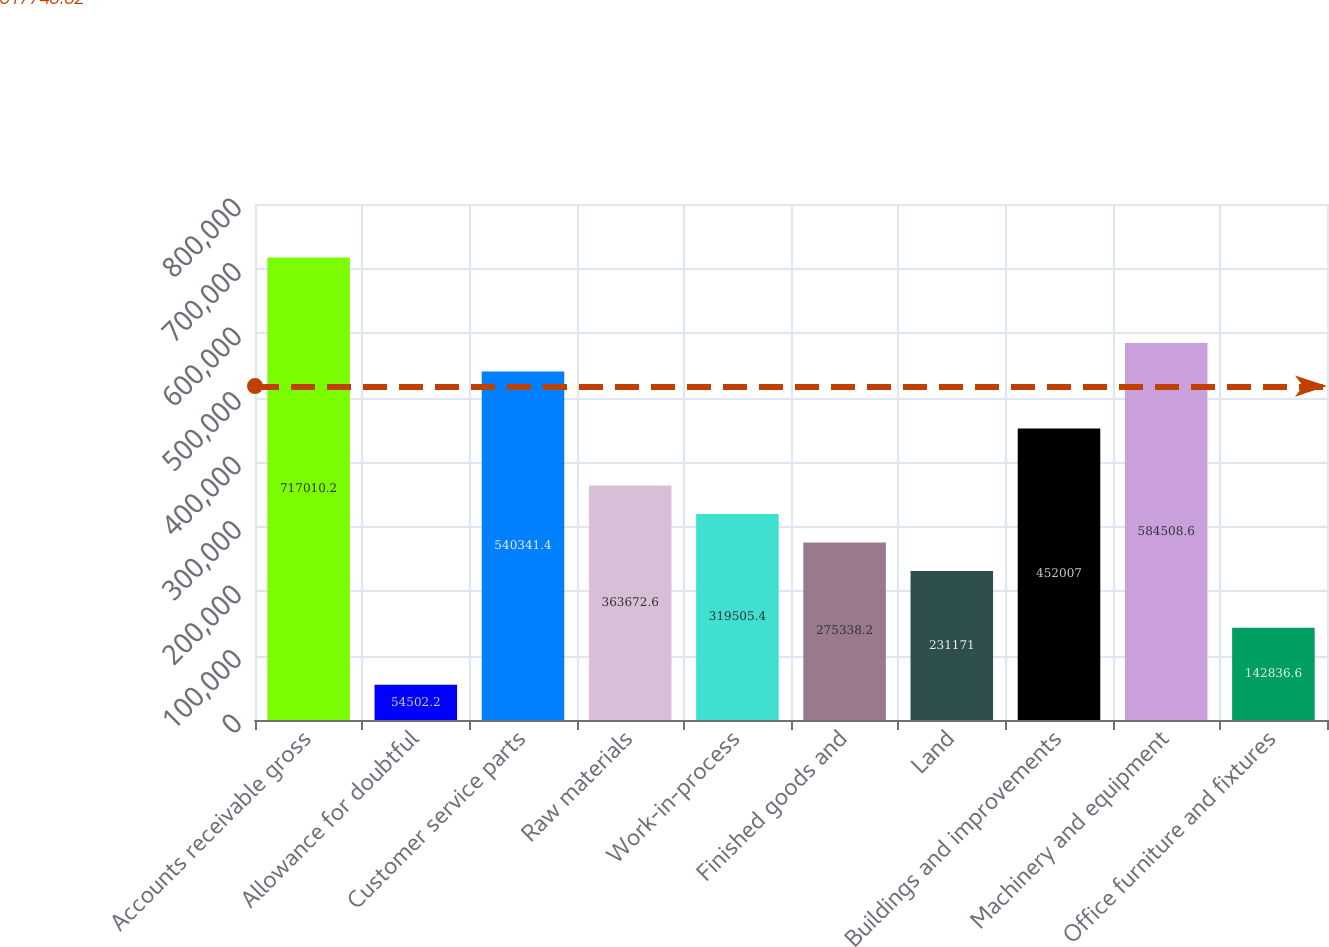<chart> <loc_0><loc_0><loc_500><loc_500><bar_chart><fcel>Accounts receivable gross<fcel>Allowance for doubtful<fcel>Customer service parts<fcel>Raw materials<fcel>Work-in-process<fcel>Finished goods and<fcel>Land<fcel>Buildings and improvements<fcel>Machinery and equipment<fcel>Office furniture and fixtures<nl><fcel>717010<fcel>54502.2<fcel>540341<fcel>363673<fcel>319505<fcel>275338<fcel>231171<fcel>452007<fcel>584509<fcel>142837<nl></chart> 